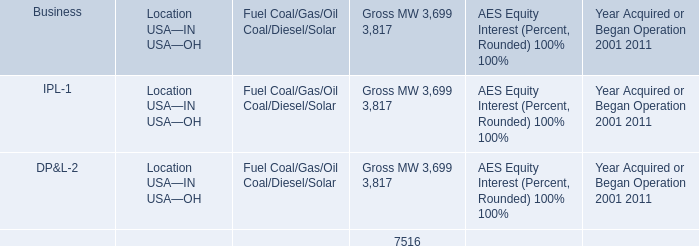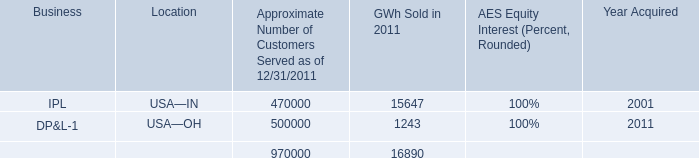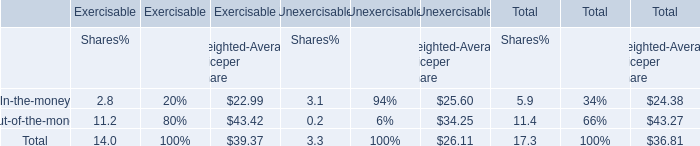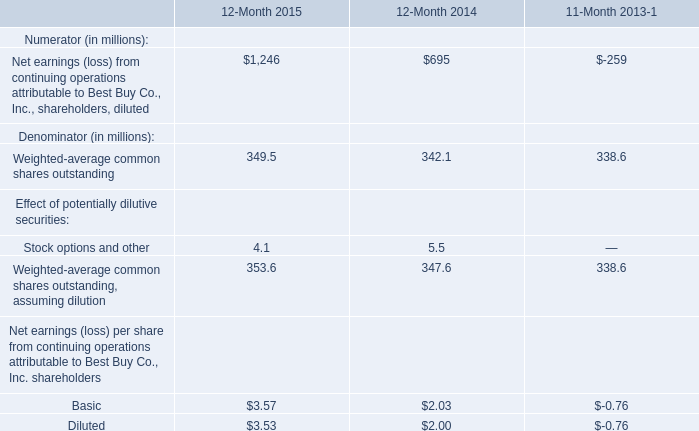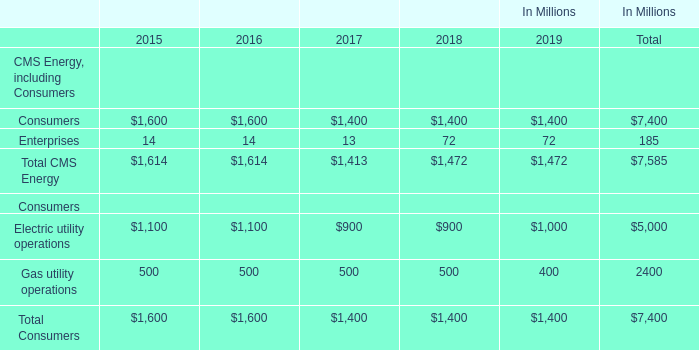What's the average of Consumers of data 2 2017, and IPL of GWh Sold in 2011 ? 
Computations: ((1400.0 + 15647.0) / 2)
Answer: 8523.5. 